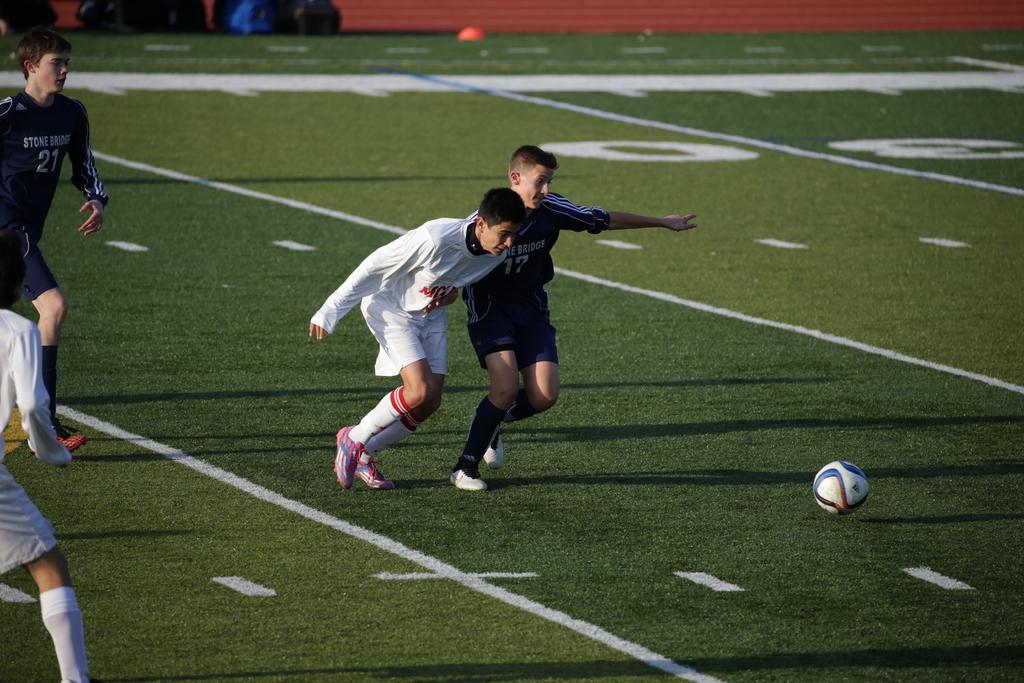What is the bridge mentioned on the black jerseys?
Ensure brevity in your answer.  Stone bridge. What number is the stone bridge player on the left wearing?
Give a very brief answer. 21. 